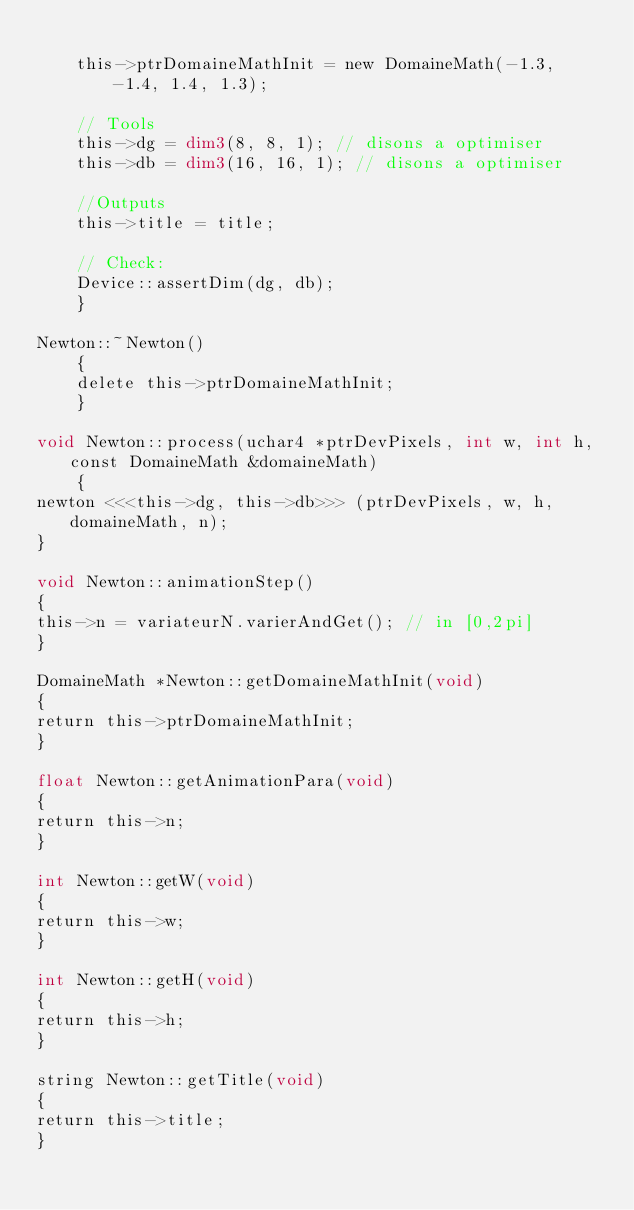Convert code to text. <code><loc_0><loc_0><loc_500><loc_500><_Cuda_>
    this->ptrDomaineMathInit = new DomaineMath(-1.3, -1.4, 1.4, 1.3);

    // Tools
    this->dg = dim3(8, 8, 1); // disons a optimiser
    this->db = dim3(16, 16, 1); // disons a optimiser

    //Outputs
    this->title = title;

    // Check:
    Device::assertDim(dg, db);
    }

Newton::~Newton()
    {
    delete this->ptrDomaineMathInit;
    }

void Newton::process(uchar4 *ptrDevPixels, int w, int h, const DomaineMath &domaineMath)
    {
newton <<<this->dg, this->db>>> (ptrDevPixels, w, h, domaineMath, n);
}

void Newton::animationStep()
{
this->n = variateurN.varierAndGet(); // in [0,2pi]
}

DomaineMath *Newton::getDomaineMathInit(void)
{
return this->ptrDomaineMathInit;
}

float Newton::getAnimationPara(void)
{
return this->n;
}

int Newton::getW(void)
{
return this->w;
}

int Newton::getH(void)
{
return this->h;
}

string Newton::getTitle(void)
{
return this->title;
}
</code> 